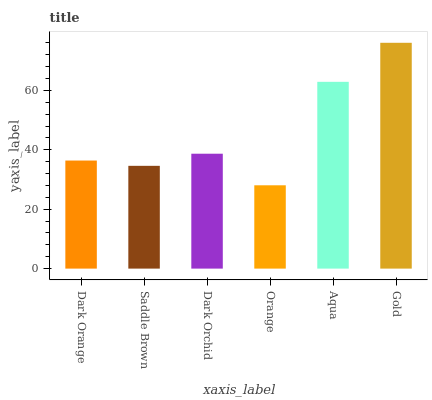Is Saddle Brown the minimum?
Answer yes or no. No. Is Saddle Brown the maximum?
Answer yes or no. No. Is Dark Orange greater than Saddle Brown?
Answer yes or no. Yes. Is Saddle Brown less than Dark Orange?
Answer yes or no. Yes. Is Saddle Brown greater than Dark Orange?
Answer yes or no. No. Is Dark Orange less than Saddle Brown?
Answer yes or no. No. Is Dark Orchid the high median?
Answer yes or no. Yes. Is Dark Orange the low median?
Answer yes or no. Yes. Is Gold the high median?
Answer yes or no. No. Is Aqua the low median?
Answer yes or no. No. 